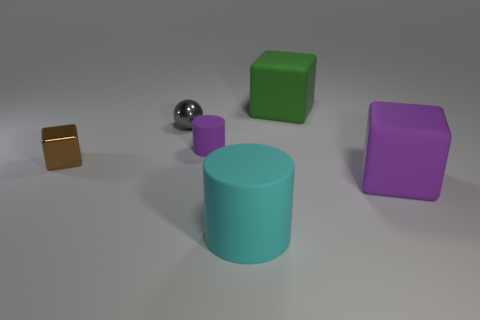Subtract 1 cubes. How many cubes are left? 2 Add 3 big yellow matte cylinders. How many objects exist? 9 Subtract all small blocks. How many blocks are left? 2 Subtract all cylinders. How many objects are left? 4 Subtract all green matte blocks. Subtract all cyan matte cylinders. How many objects are left? 4 Add 4 small gray metal balls. How many small gray metal balls are left? 5 Add 3 cyan shiny cylinders. How many cyan shiny cylinders exist? 3 Subtract 0 yellow balls. How many objects are left? 6 